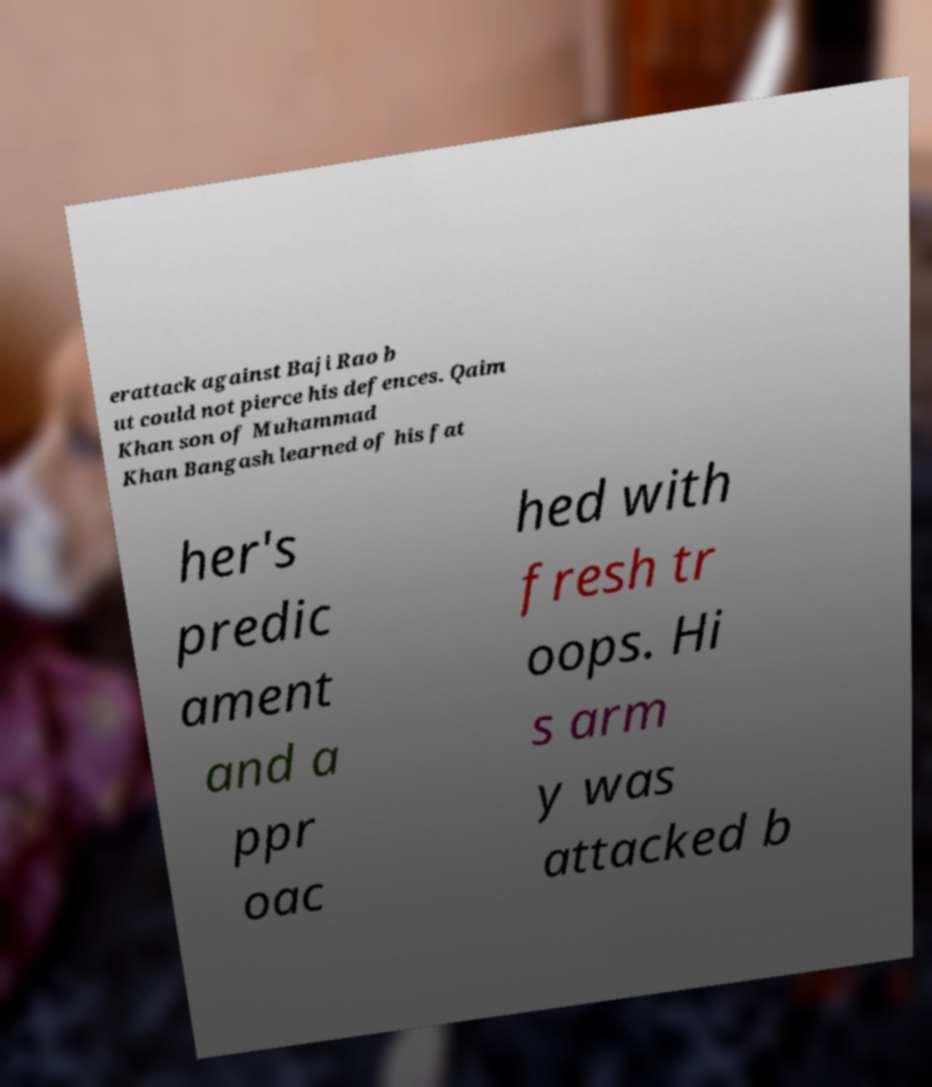Could you assist in decoding the text presented in this image and type it out clearly? erattack against Baji Rao b ut could not pierce his defences. Qaim Khan son of Muhammad Khan Bangash learned of his fat her's predic ament and a ppr oac hed with fresh tr oops. Hi s arm y was attacked b 